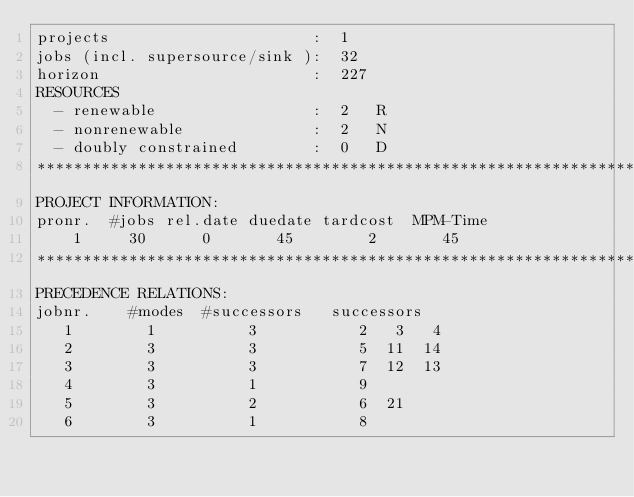<code> <loc_0><loc_0><loc_500><loc_500><_ObjectiveC_>projects                      :  1
jobs (incl. supersource/sink ):  32
horizon                       :  227
RESOURCES
  - renewable                 :  2   R
  - nonrenewable              :  2   N
  - doubly constrained        :  0   D
************************************************************************
PROJECT INFORMATION:
pronr.  #jobs rel.date duedate tardcost  MPM-Time
    1     30      0       45        2       45
************************************************************************
PRECEDENCE RELATIONS:
jobnr.    #modes  #successors   successors
   1        1          3           2   3   4
   2        3          3           5  11  14
   3        3          3           7  12  13
   4        3          1           9
   5        3          2           6  21
   6        3          1           8</code> 